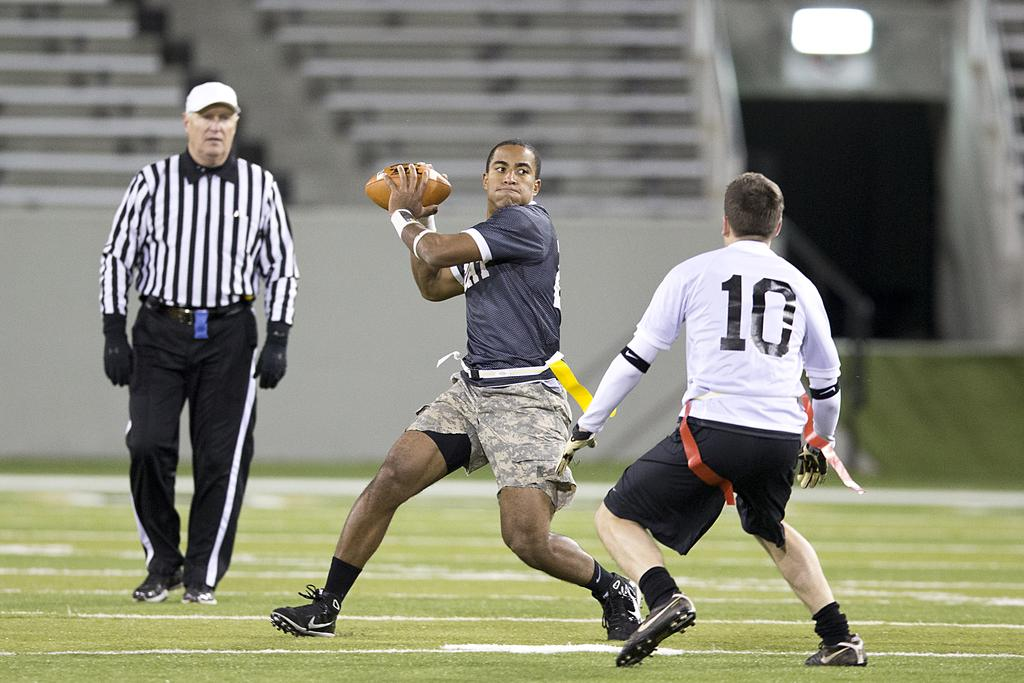How many people are in the image? There are three persons in the image. What are two of the persons doing? Two of the persons are playing with a ball. What is the action of the third person? One person is walking. Can you describe the setting of the image? The setting is on a ground. What book is the woman reading in the image? There is no woman or book present in the image. How many hats can be seen on the persons in the image? There are no hats visible in the image. 